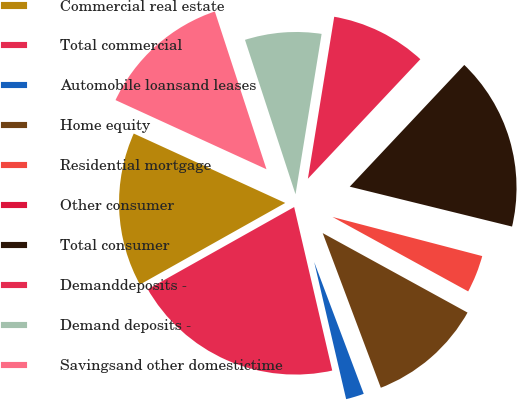<chart> <loc_0><loc_0><loc_500><loc_500><pie_chart><fcel>Commercial real estate<fcel>Total commercial<fcel>Automobile loansand leases<fcel>Home equity<fcel>Residential mortgage<fcel>Other consumer<fcel>Total consumer<fcel>Demanddeposits -<fcel>Demand deposits -<fcel>Savingsand other domestictime<nl><fcel>14.98%<fcel>20.5%<fcel>2.08%<fcel>11.29%<fcel>3.92%<fcel>0.23%<fcel>16.82%<fcel>9.45%<fcel>7.6%<fcel>13.13%<nl></chart> 